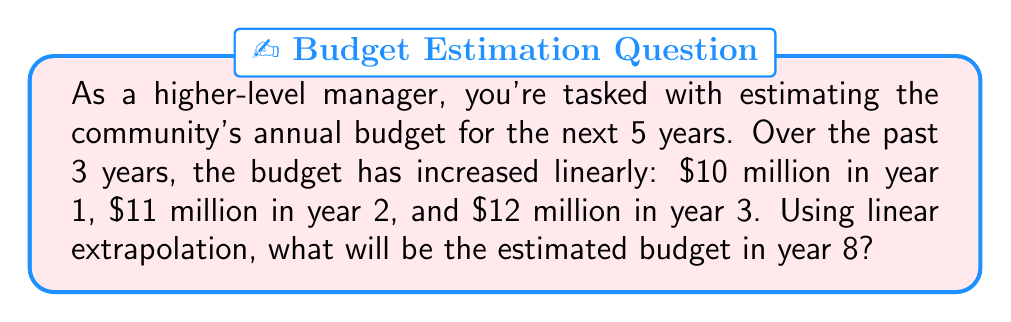Could you help me with this problem? To solve this problem, we'll use linear extrapolation based on the given data:

1. Identify the pattern:
   Year 1: $10 million
   Year 2: $11 million
   Year 3: $12 million

2. Calculate the annual increase:
   $\text{Annual increase} = \frac{\$12\text{ million} - \$10\text{ million}}{3 - 1} = \$1\text{ million per year}$

3. Form a linear equation:
   Let $y$ be the budget in millions and $x$ be the year number.
   $y = mx + b$, where $m$ is the slope (annual increase) and $b$ is the y-intercept.

4. Find the y-intercept:
   Using Year 1 data: $10 = 1(1) + b$
   $b = 9$

5. Write the complete linear equation:
   $y = 1x + 9$

6. Use the equation to estimate the budget for Year 8:
   $y = 1(8) + 9 = 17$

Therefore, the estimated budget for Year 8 is $17 million.
Answer: $17 million 